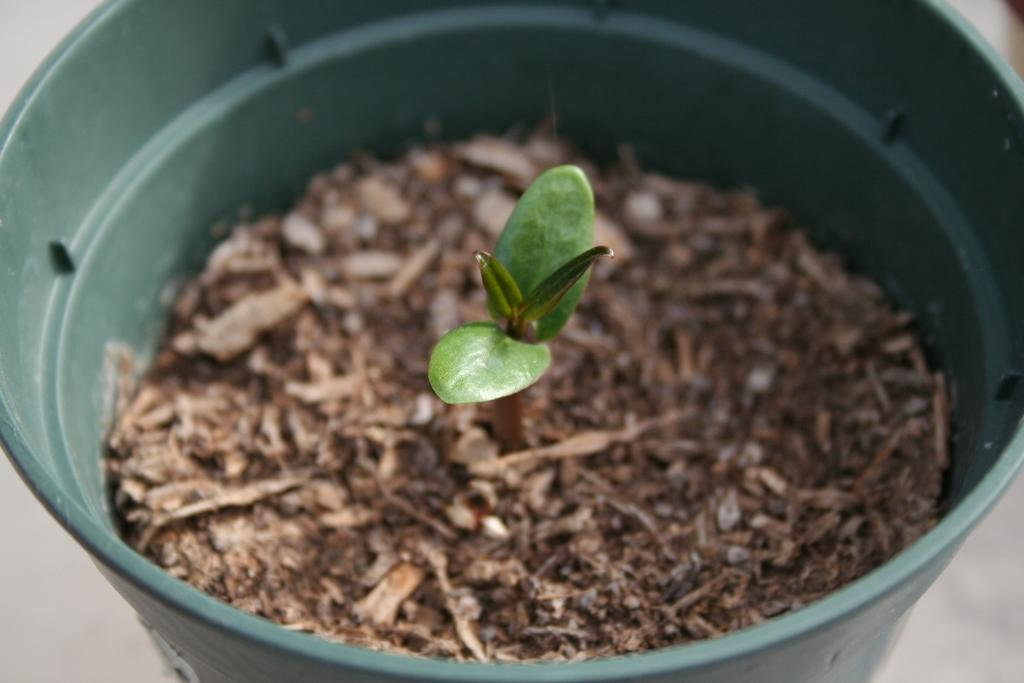What is on the floor in the image? There is a bucket on the floor. What is inside the bucket? The bucket contains dried sticks and mud. What can be seen growing in the mud? There is a sapling in the mud. What is the best route to take to reach the nail in the image? There is no nail present in the image, so there is no route to reach it. 